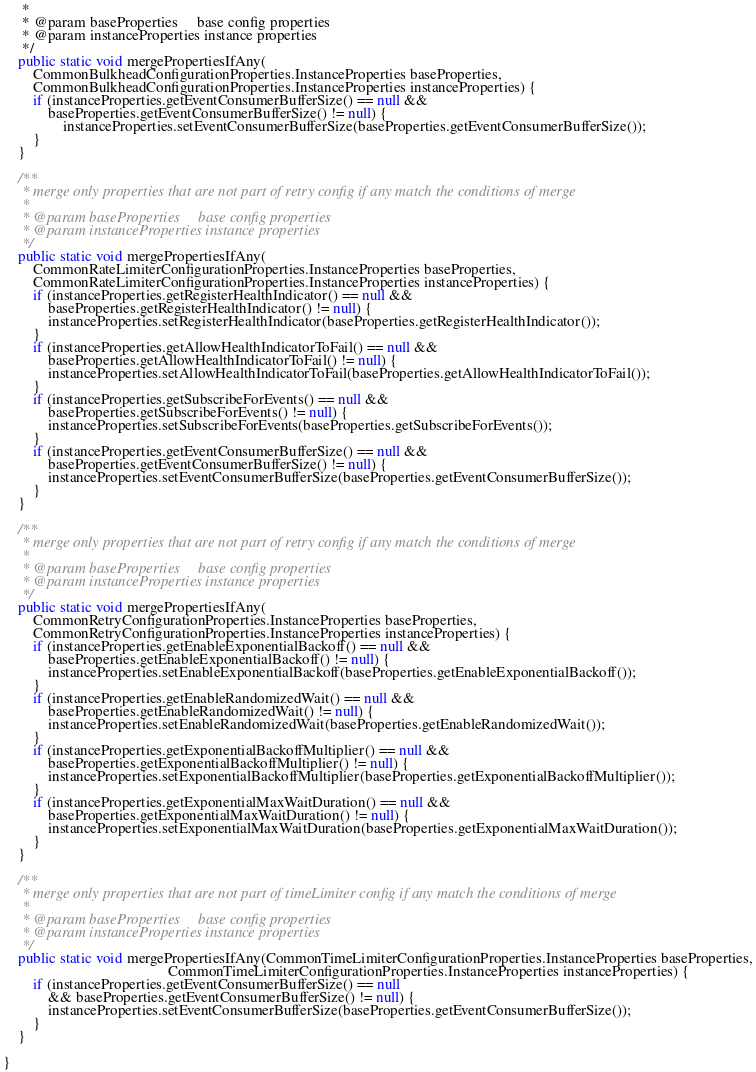Convert code to text. <code><loc_0><loc_0><loc_500><loc_500><_Java_>     *
     * @param baseProperties     base config properties
     * @param instanceProperties instance properties
     */
    public static void mergePropertiesIfAny(
        CommonBulkheadConfigurationProperties.InstanceProperties baseProperties,
        CommonBulkheadConfigurationProperties.InstanceProperties instanceProperties) {
        if (instanceProperties.getEventConsumerBufferSize() == null &&
            baseProperties.getEventConsumerBufferSize() != null) {
                instanceProperties.setEventConsumerBufferSize(baseProperties.getEventConsumerBufferSize());
        }
    }

    /**
     * merge only properties that are not part of retry config if any match the conditions of merge
     *
     * @param baseProperties     base config properties
     * @param instanceProperties instance properties
     */
    public static void mergePropertiesIfAny(
        CommonRateLimiterConfigurationProperties.InstanceProperties baseProperties,
        CommonRateLimiterConfigurationProperties.InstanceProperties instanceProperties) {
        if (instanceProperties.getRegisterHealthIndicator() == null &&
            baseProperties.getRegisterHealthIndicator() != null) {
            instanceProperties.setRegisterHealthIndicator(baseProperties.getRegisterHealthIndicator());
        }
        if (instanceProperties.getAllowHealthIndicatorToFail() == null &&
            baseProperties.getAllowHealthIndicatorToFail() != null) {
            instanceProperties.setAllowHealthIndicatorToFail(baseProperties.getAllowHealthIndicatorToFail());
        }
        if (instanceProperties.getSubscribeForEvents() == null &&
            baseProperties.getSubscribeForEvents() != null) {
            instanceProperties.setSubscribeForEvents(baseProperties.getSubscribeForEvents());
        }
        if (instanceProperties.getEventConsumerBufferSize() == null &&
            baseProperties.getEventConsumerBufferSize() != null) {
            instanceProperties.setEventConsumerBufferSize(baseProperties.getEventConsumerBufferSize());
        }
    }

    /**
     * merge only properties that are not part of retry config if any match the conditions of merge
     *
     * @param baseProperties     base config properties
     * @param instanceProperties instance properties
     */
    public static void mergePropertiesIfAny(
        CommonRetryConfigurationProperties.InstanceProperties baseProperties,
        CommonRetryConfigurationProperties.InstanceProperties instanceProperties) {
        if (instanceProperties.getEnableExponentialBackoff() == null &&
            baseProperties.getEnableExponentialBackoff() != null) {
            instanceProperties.setEnableExponentialBackoff(baseProperties.getEnableExponentialBackoff());
        }
        if (instanceProperties.getEnableRandomizedWait() == null &&
            baseProperties.getEnableRandomizedWait() != null) {
            instanceProperties.setEnableRandomizedWait(baseProperties.getEnableRandomizedWait());
        }
        if (instanceProperties.getExponentialBackoffMultiplier() == null &&
            baseProperties.getExponentialBackoffMultiplier() != null) {
            instanceProperties.setExponentialBackoffMultiplier(baseProperties.getExponentialBackoffMultiplier());
        }
        if (instanceProperties.getExponentialMaxWaitDuration() == null &&
            baseProperties.getExponentialMaxWaitDuration() != null) {
            instanceProperties.setExponentialMaxWaitDuration(baseProperties.getExponentialMaxWaitDuration());
        }
    }

	/**
	 * merge only properties that are not part of timeLimiter config if any match the conditions of merge
	 *
	 * @param baseProperties     base config properties
	 * @param instanceProperties instance properties
	 */
	public static void mergePropertiesIfAny(CommonTimeLimiterConfigurationProperties.InstanceProperties baseProperties,
											CommonTimeLimiterConfigurationProperties.InstanceProperties instanceProperties) {
		if (instanceProperties.getEventConsumerBufferSize() == null
            && baseProperties.getEventConsumerBufferSize() != null) {
            instanceProperties.setEventConsumerBufferSize(baseProperties.getEventConsumerBufferSize());
		}
	}

}
</code> 